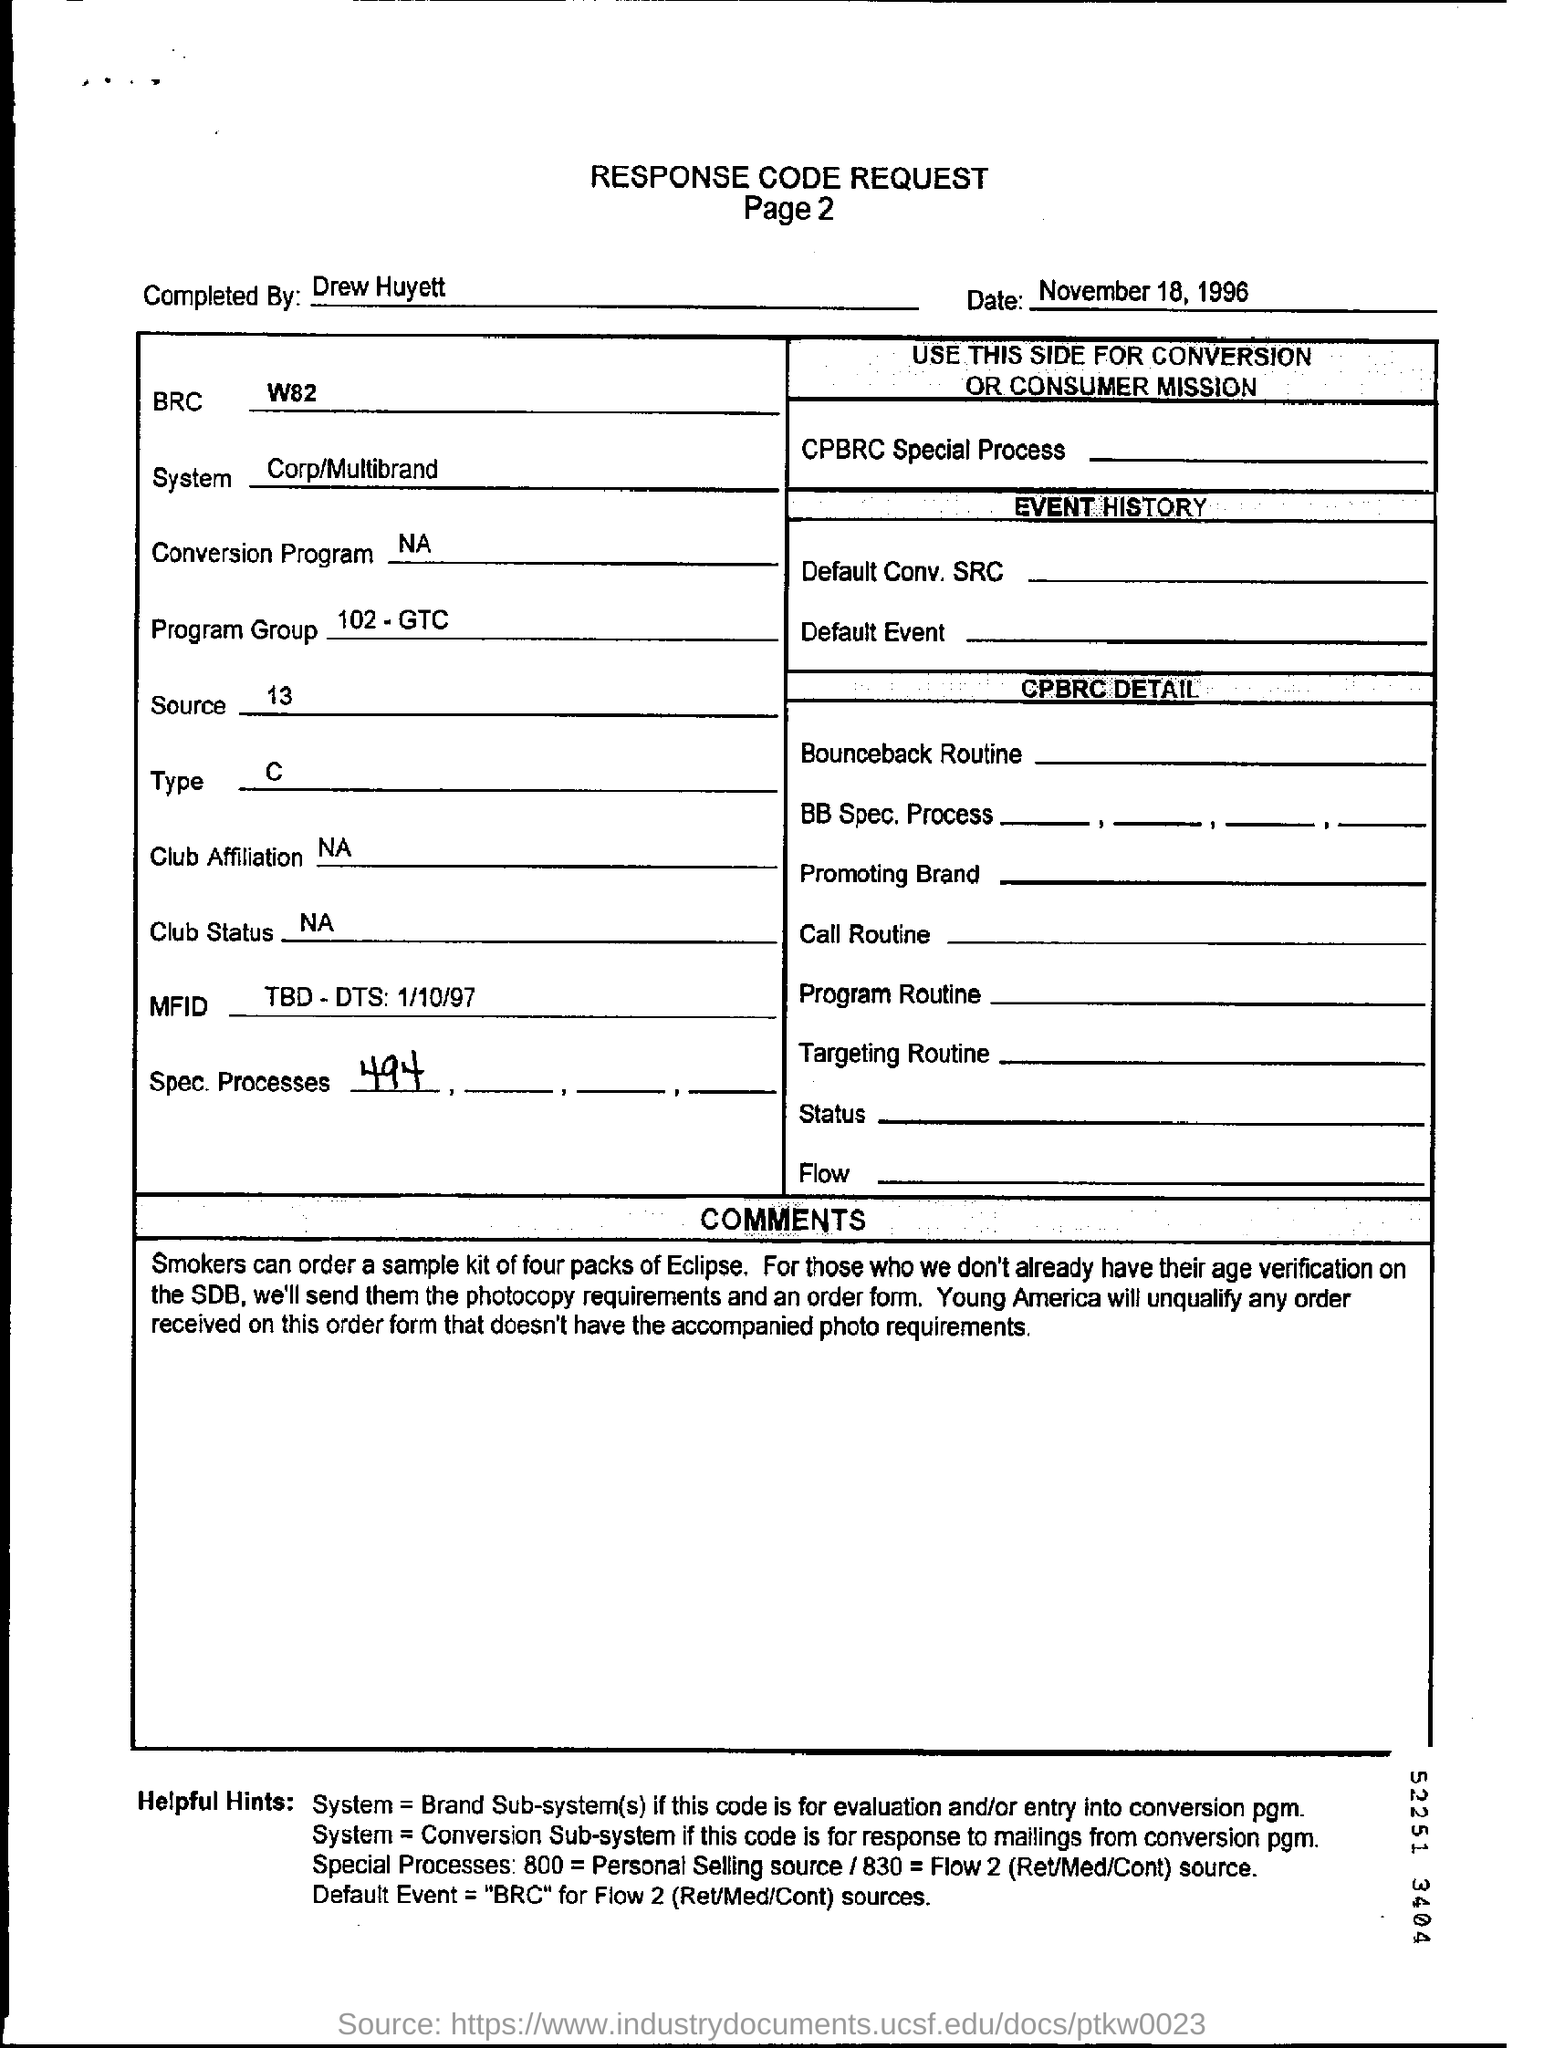Draw attention to some important aspects in this diagram. The date mentioned in the form is November 18, 1996. The type that is mentioned is C... The individual who completed this request form is Drew Huyett. 